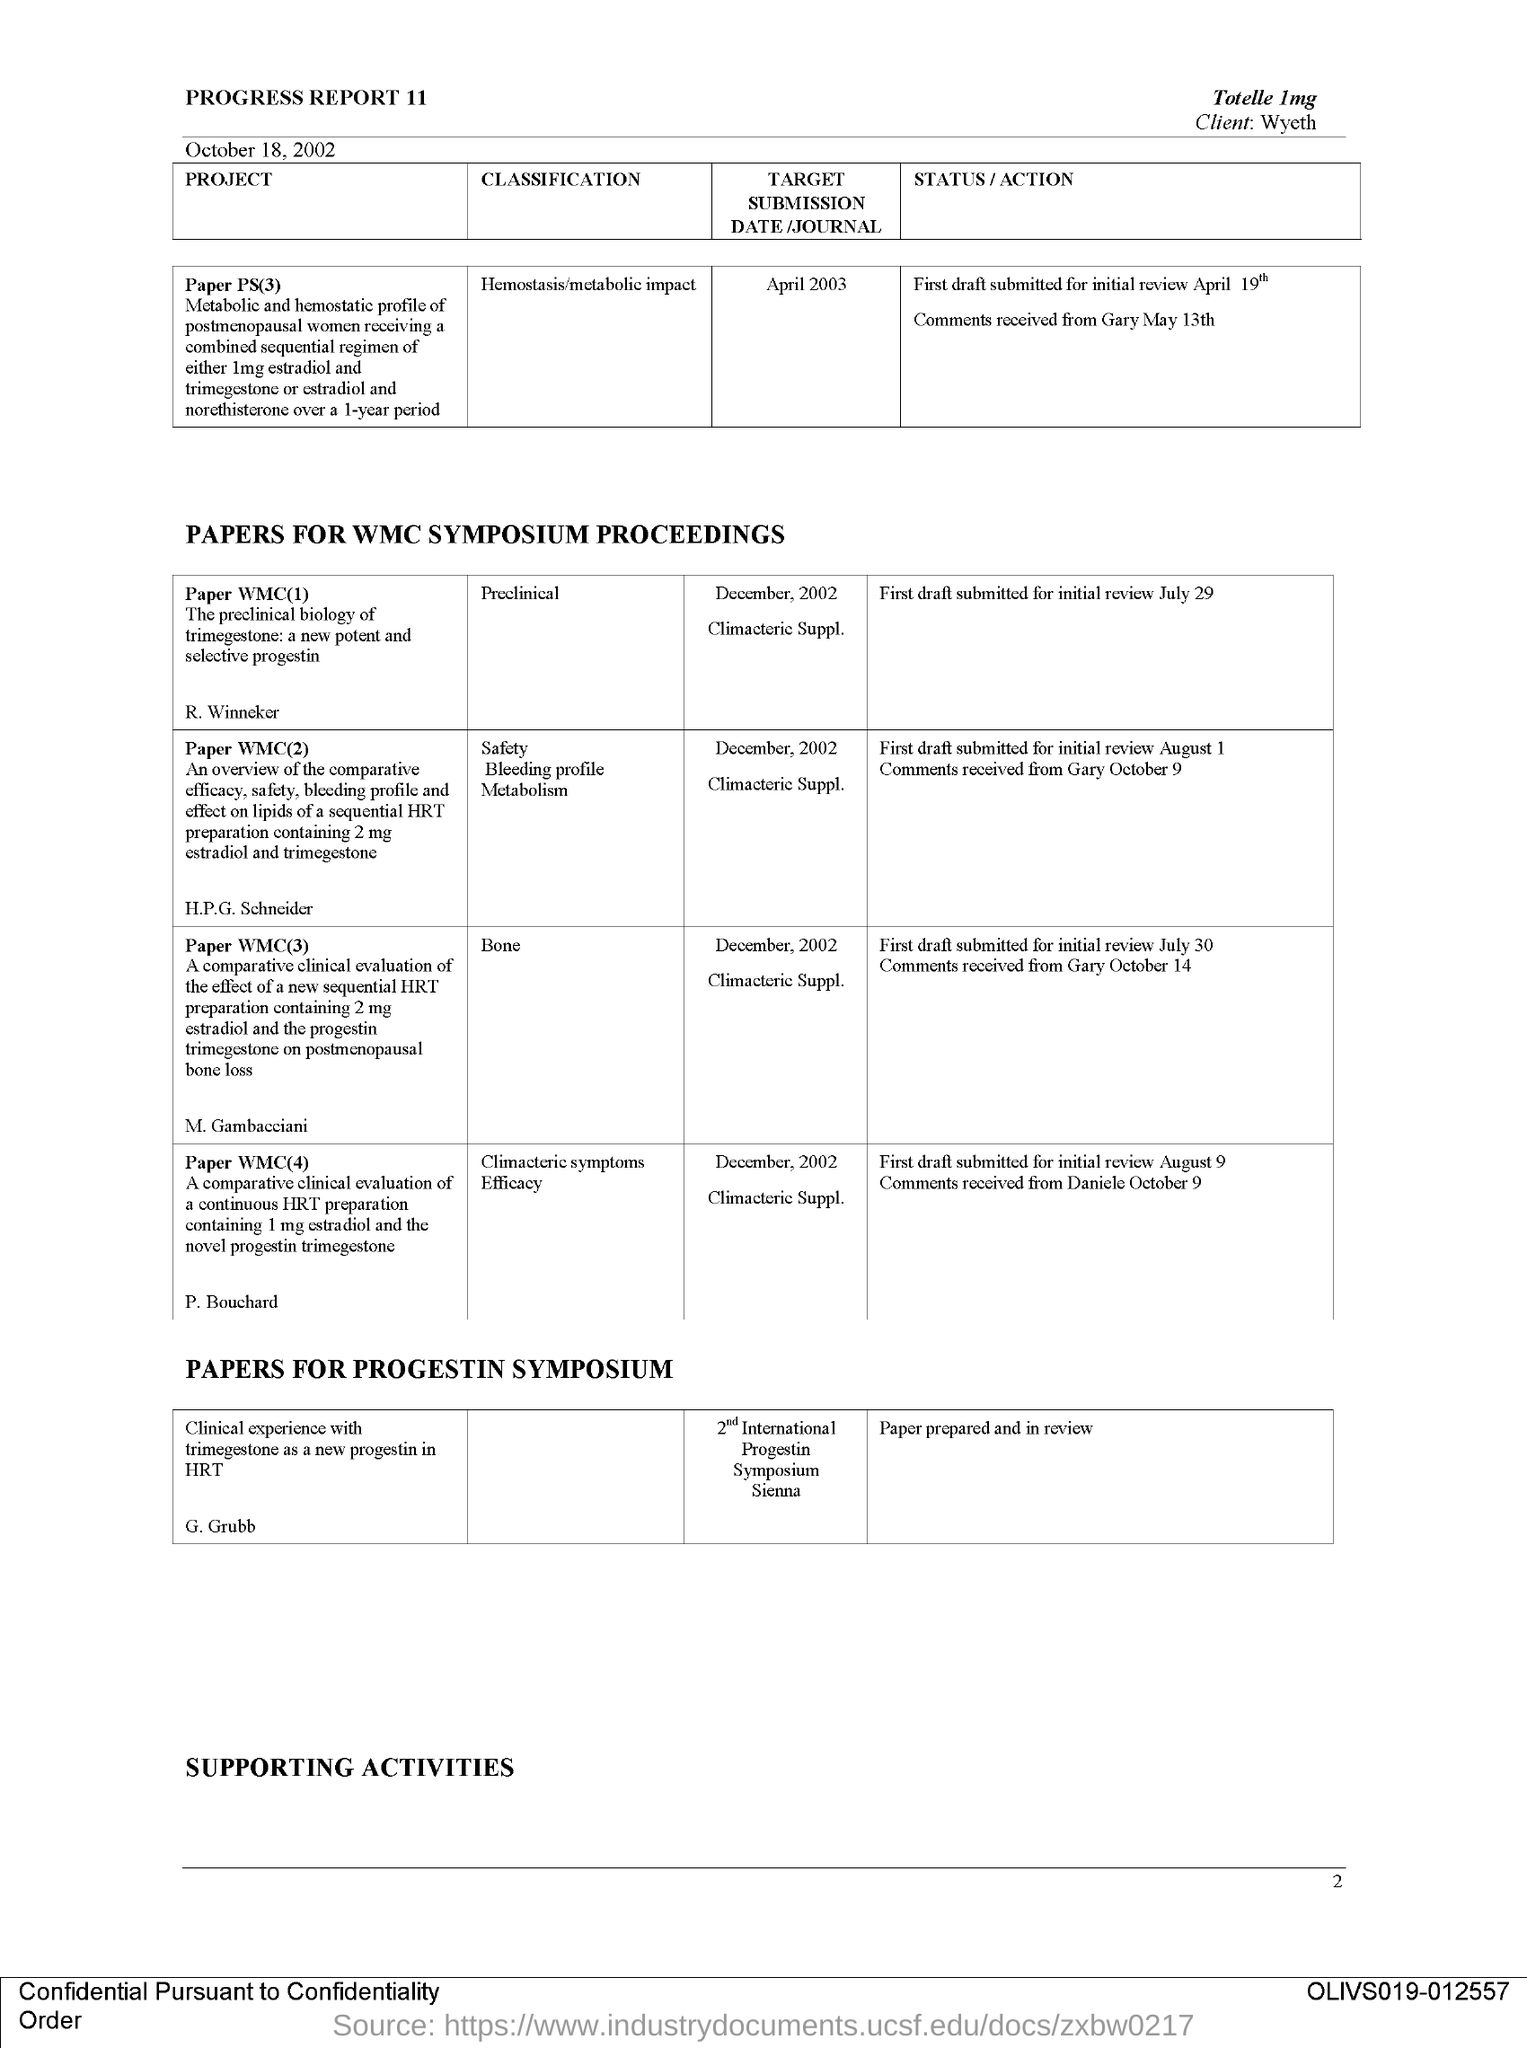What is the page number?
Your answer should be compact. 2. What is the second title in the document?
Your answer should be very brief. Papers for WMC symposium proceedings. Paper WMC(1) belongs to which classification?
Ensure brevity in your answer.  Preclinical. Paper WMC(3) belongs to which classification?
Your answer should be compact. Bone. What is the date of submission of the project "Paper PS(3)"?
Ensure brevity in your answer.  April 2003. 